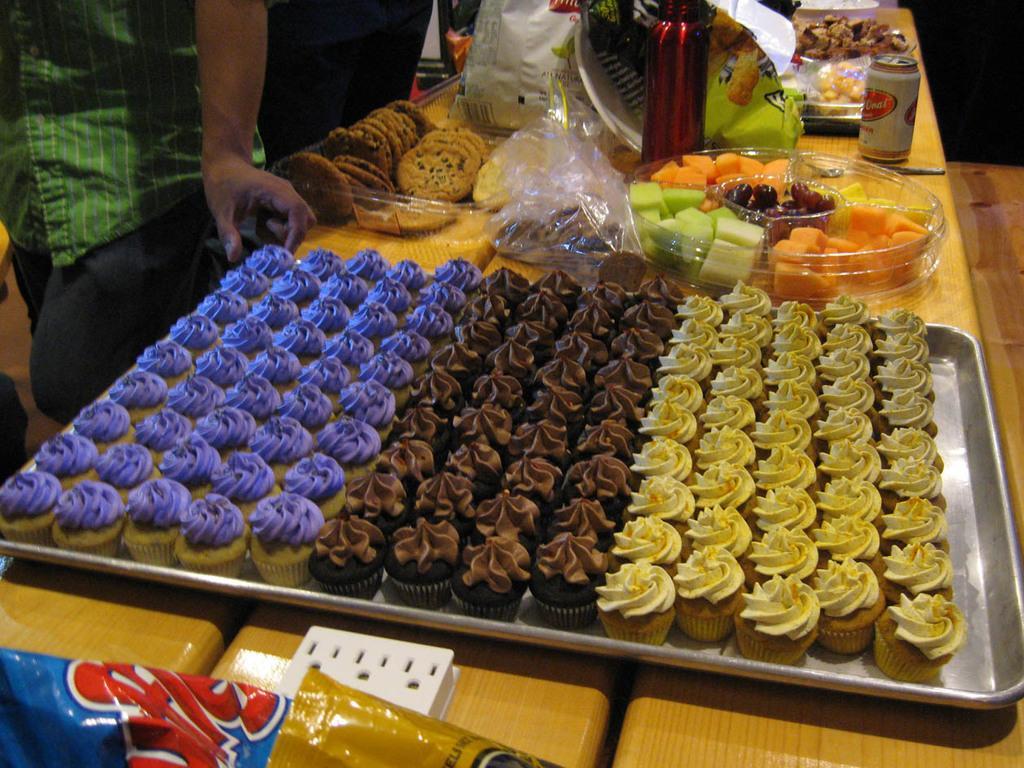How would you summarize this image in a sentence or two? In this image I can see few cupcakes in the tray and the cakes are in brown, purple and yellow color and I can also see few food items on the table. Background I can see few persons standing. 